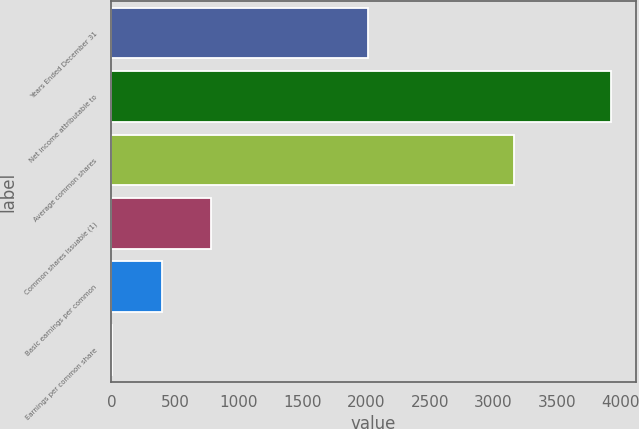Convert chart to OTSL. <chart><loc_0><loc_0><loc_500><loc_500><bar_chart><fcel>Years Ended December 31<fcel>Net income attributable to<fcel>Average common shares<fcel>Common shares issuable (1)<fcel>Basic earnings per common<fcel>Earnings per common share<nl><fcel>2016<fcel>3920<fcel>3157.86<fcel>785.13<fcel>393.27<fcel>1.41<nl></chart> 